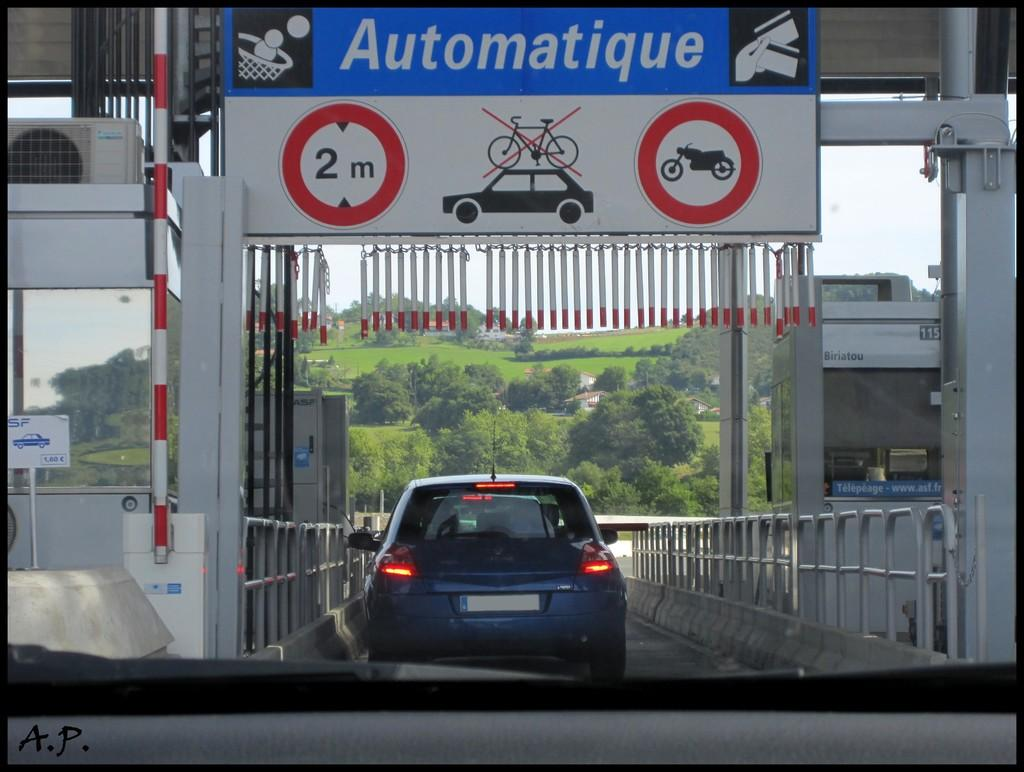What can be seen on the road in the image? There are vehicles on the road in the image. What type of structures can be seen in the image? There are fences, sheds, and a signboard in the image. What is hanging in the image? There is a banner in the image. What type of cooling system is visible in the image? There is an AC (air conditioner) in the image. What type of vertical structures can be seen in the image? There are poles in the image. What type of vegetation can be seen in the image? There are trees and grass in the image. What is visible in the background of the image? The sky is visible in the background of the image. Can you tell me how many caves are depicted in the image? There are no caves present in the image. What is the level of friction between the vehicles and the road in the image? The image does not provide information about the friction between the vehicles and the road. 